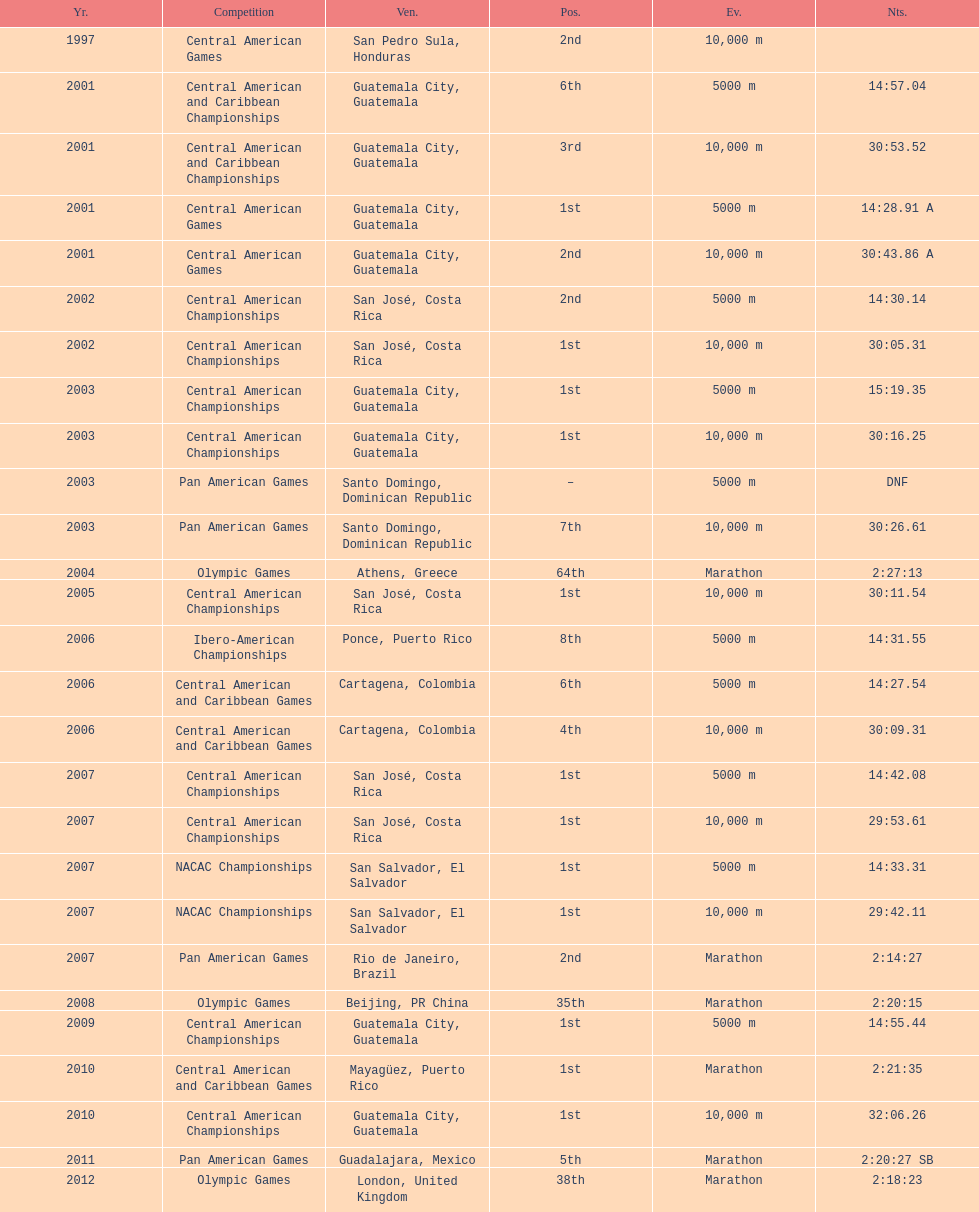How many times has this athlete not finished in a competition? 1. Can you parse all the data within this table? {'header': ['Yr.', 'Competition', 'Ven.', 'Pos.', 'Ev.', 'Nts.'], 'rows': [['1997', 'Central American Games', 'San Pedro Sula, Honduras', '2nd', '10,000 m', ''], ['2001', 'Central American and Caribbean Championships', 'Guatemala City, Guatemala', '6th', '5000 m', '14:57.04'], ['2001', 'Central American and Caribbean Championships', 'Guatemala City, Guatemala', '3rd', '10,000 m', '30:53.52'], ['2001', 'Central American Games', 'Guatemala City, Guatemala', '1st', '5000 m', '14:28.91 A'], ['2001', 'Central American Games', 'Guatemala City, Guatemala', '2nd', '10,000 m', '30:43.86 A'], ['2002', 'Central American Championships', 'San José, Costa Rica', '2nd', '5000 m', '14:30.14'], ['2002', 'Central American Championships', 'San José, Costa Rica', '1st', '10,000 m', '30:05.31'], ['2003', 'Central American Championships', 'Guatemala City, Guatemala', '1st', '5000 m', '15:19.35'], ['2003', 'Central American Championships', 'Guatemala City, Guatemala', '1st', '10,000 m', '30:16.25'], ['2003', 'Pan American Games', 'Santo Domingo, Dominican Republic', '–', '5000 m', 'DNF'], ['2003', 'Pan American Games', 'Santo Domingo, Dominican Republic', '7th', '10,000 m', '30:26.61'], ['2004', 'Olympic Games', 'Athens, Greece', '64th', 'Marathon', '2:27:13'], ['2005', 'Central American Championships', 'San José, Costa Rica', '1st', '10,000 m', '30:11.54'], ['2006', 'Ibero-American Championships', 'Ponce, Puerto Rico', '8th', '5000 m', '14:31.55'], ['2006', 'Central American and Caribbean Games', 'Cartagena, Colombia', '6th', '5000 m', '14:27.54'], ['2006', 'Central American and Caribbean Games', 'Cartagena, Colombia', '4th', '10,000 m', '30:09.31'], ['2007', 'Central American Championships', 'San José, Costa Rica', '1st', '5000 m', '14:42.08'], ['2007', 'Central American Championships', 'San José, Costa Rica', '1st', '10,000 m', '29:53.61'], ['2007', 'NACAC Championships', 'San Salvador, El Salvador', '1st', '5000 m', '14:33.31'], ['2007', 'NACAC Championships', 'San Salvador, El Salvador', '1st', '10,000 m', '29:42.11'], ['2007', 'Pan American Games', 'Rio de Janeiro, Brazil', '2nd', 'Marathon', '2:14:27'], ['2008', 'Olympic Games', 'Beijing, PR China', '35th', 'Marathon', '2:20:15'], ['2009', 'Central American Championships', 'Guatemala City, Guatemala', '1st', '5000 m', '14:55.44'], ['2010', 'Central American and Caribbean Games', 'Mayagüez, Puerto Rico', '1st', 'Marathon', '2:21:35'], ['2010', 'Central American Championships', 'Guatemala City, Guatemala', '1st', '10,000 m', '32:06.26'], ['2011', 'Pan American Games', 'Guadalajara, Mexico', '5th', 'Marathon', '2:20:27 SB'], ['2012', 'Olympic Games', 'London, United Kingdom', '38th', 'Marathon', '2:18:23']]} 